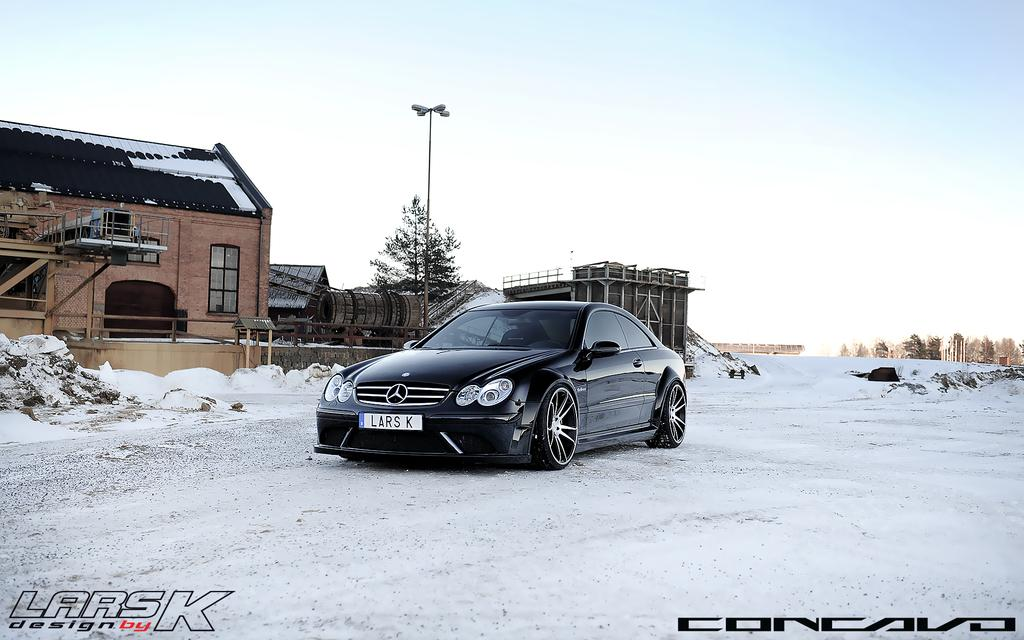What is the main subject of the image? There is a car in the image. What else can be seen in the image besides the car? There are buildings, a pole, trees, and snow on the ground in the image. The sky is also visible in the background. What is the condition of the ground in the image? There is snow on the ground in the image. What type of markings are present at the bottom of the image? There are watermarks at the bottom of the image. What type of dress is the stick wearing in the image? There is no stick or dress present in the image. What substance is being used to create the snow in the image? The image does not provide information about how the snow was created or what substance was used to create it. 